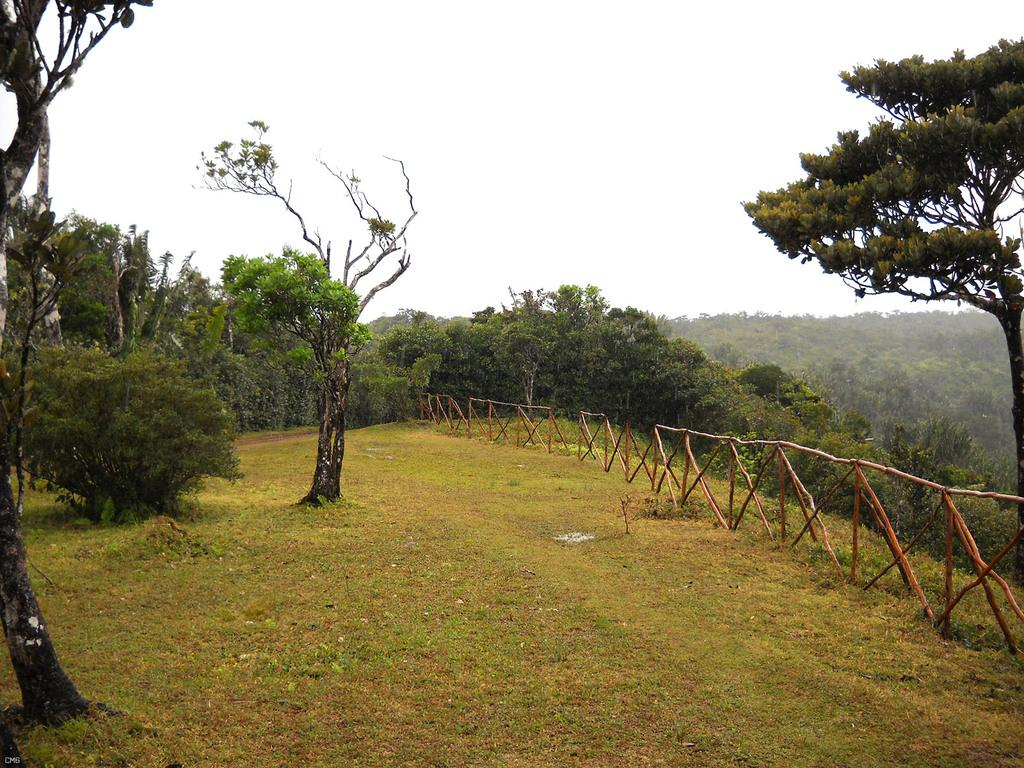What type of vegetation can be seen in the image? There are trees in the image. What is located on the ground in the image? There is a wooden fence on the ground in the image. What can be seen in the background of the image? The sky is visible in the background of the image. What type of plantation is visible in the image? There is no plantation present in the image; it only features trees and a wooden fence. How many clouds can be seen in the image? The provided facts do not mention any clouds in the image, so we cannot determine the number of clouds. 